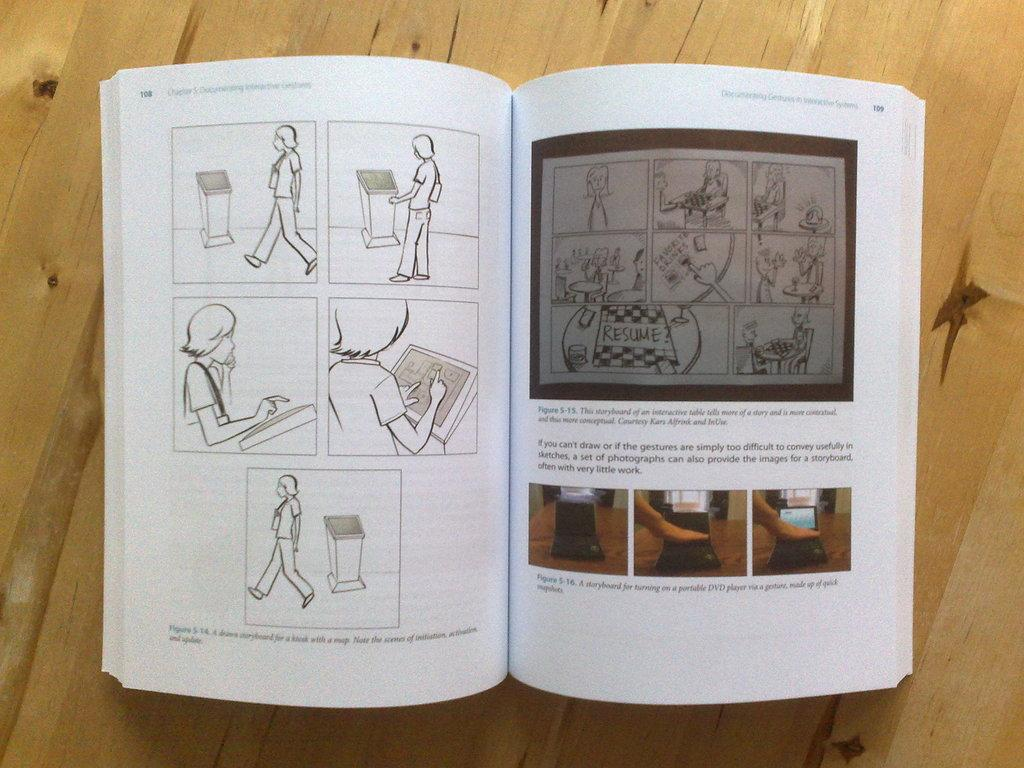<image>
Summarize the visual content of the image. Book that has pictures and says page 108 on it. 